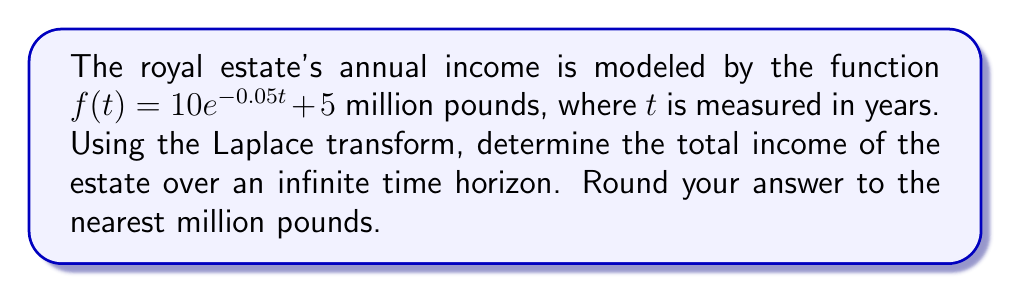Could you help me with this problem? Let's approach this step-by-step:

1) The Laplace transform of $f(t)$ is given by:

   $$F(s) = \mathcal{L}\{f(t)\} = \int_0^\infty f(t)e^{-st}dt$$

2) Substituting our function:

   $$F(s) = \int_0^\infty (10e^{-0.05t} + 5)e^{-st}dt$$

3) We can split this into two integrals:

   $$F(s) = 10\int_0^\infty e^{-(s+0.05)t}dt + 5\int_0^\infty e^{-st}dt$$

4) These are standard Laplace transform integrals:

   $$F(s) = \frac{10}{s+0.05} + \frac{5}{s}$$

5) To find the total income over an infinite time horizon, we need to evaluate $F(s)$ at $s=0$:

   $$\lim_{s \to 0} F(s) = \lim_{s \to 0} (\frac{10}{s+0.05} + \frac{5}{s})$$

6) As $s$ approaches 0, the second term becomes undefined. This indicates that the total income over an infinite time horizon is infinite. However, we can interpret the first term as the contribution from the decaying part of the income, and the second term as the contribution from the constant part.

7) The contribution from the decaying part is finite:

   $$\lim_{s \to 0} \frac{10}{s+0.05} = \frac{10}{0.05} = 200$$

8) The contribution from the constant part grows linearly with time, which is why it becomes infinite over an infinite time horizon.

9) Therefore, we can say that the estate will earn 200 million pounds from the decaying part of the income, plus an additional 5 million pounds per year indefinitely from the constant part.
Answer: The total income over an infinite time horizon is infinite. However, the estate will earn 200 million pounds from the decaying part of the income, plus an additional 5 million pounds per year indefinitely from the constant part. 